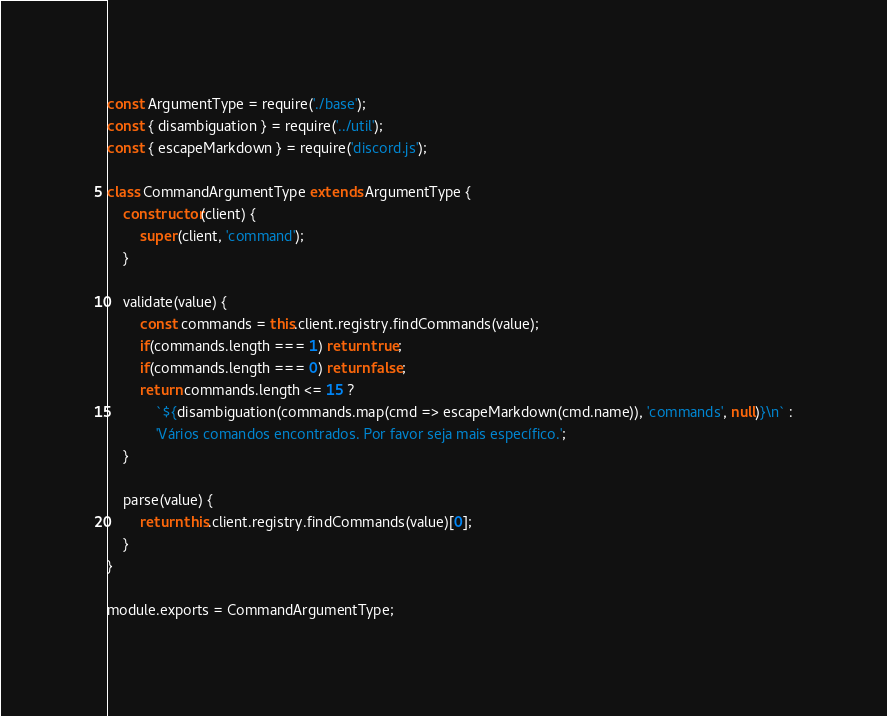<code> <loc_0><loc_0><loc_500><loc_500><_JavaScript_>const ArgumentType = require('./base');
const { disambiguation } = require('../util');
const { escapeMarkdown } = require('discord.js');

class CommandArgumentType extends ArgumentType {
	constructor(client) {
		super(client, 'command');
	}

	validate(value) {
		const commands = this.client.registry.findCommands(value);
		if(commands.length === 1) return true;
		if(commands.length === 0) return false;
		return commands.length <= 15 ?
			`${disambiguation(commands.map(cmd => escapeMarkdown(cmd.name)), 'commands', null)}\n` :
			'Vários comandos encontrados. Por favor seja mais específico.';
	}

	parse(value) {
		return this.client.registry.findCommands(value)[0];
	}
}

module.exports = CommandArgumentType;
</code> 